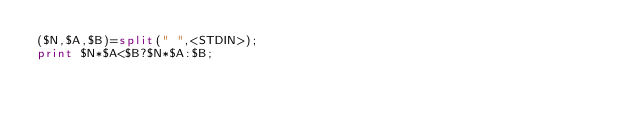<code> <loc_0><loc_0><loc_500><loc_500><_Perl_>($N,$A,$B)=split(" ",<STDIN>);
print $N*$A<$B?$N*$A:$B;
</code> 